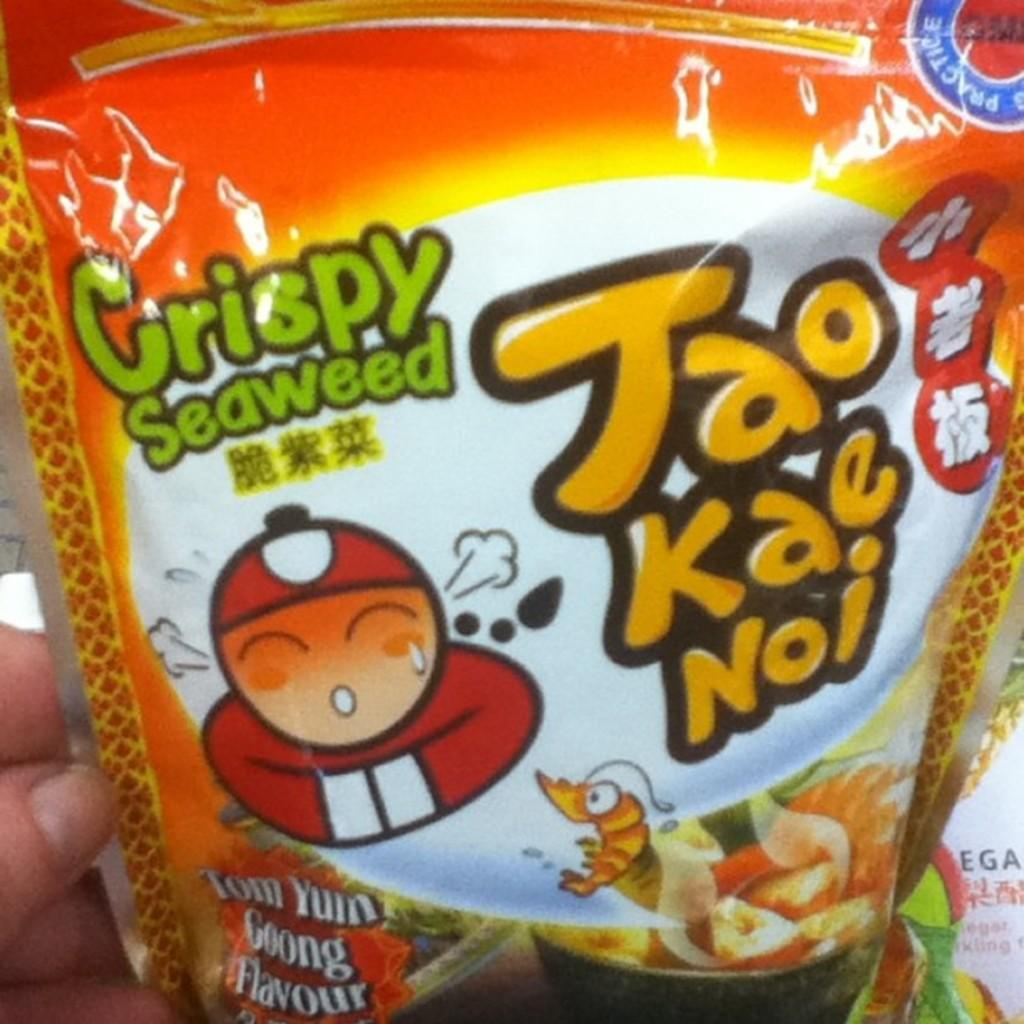What object is being held by a person in the image? There is a sachet in the image, and it is being held by a person. What type of brass instrument is being played during the feast in the image? There is no feast or brass instrument present in the image; it only features a person holding a sachet. 